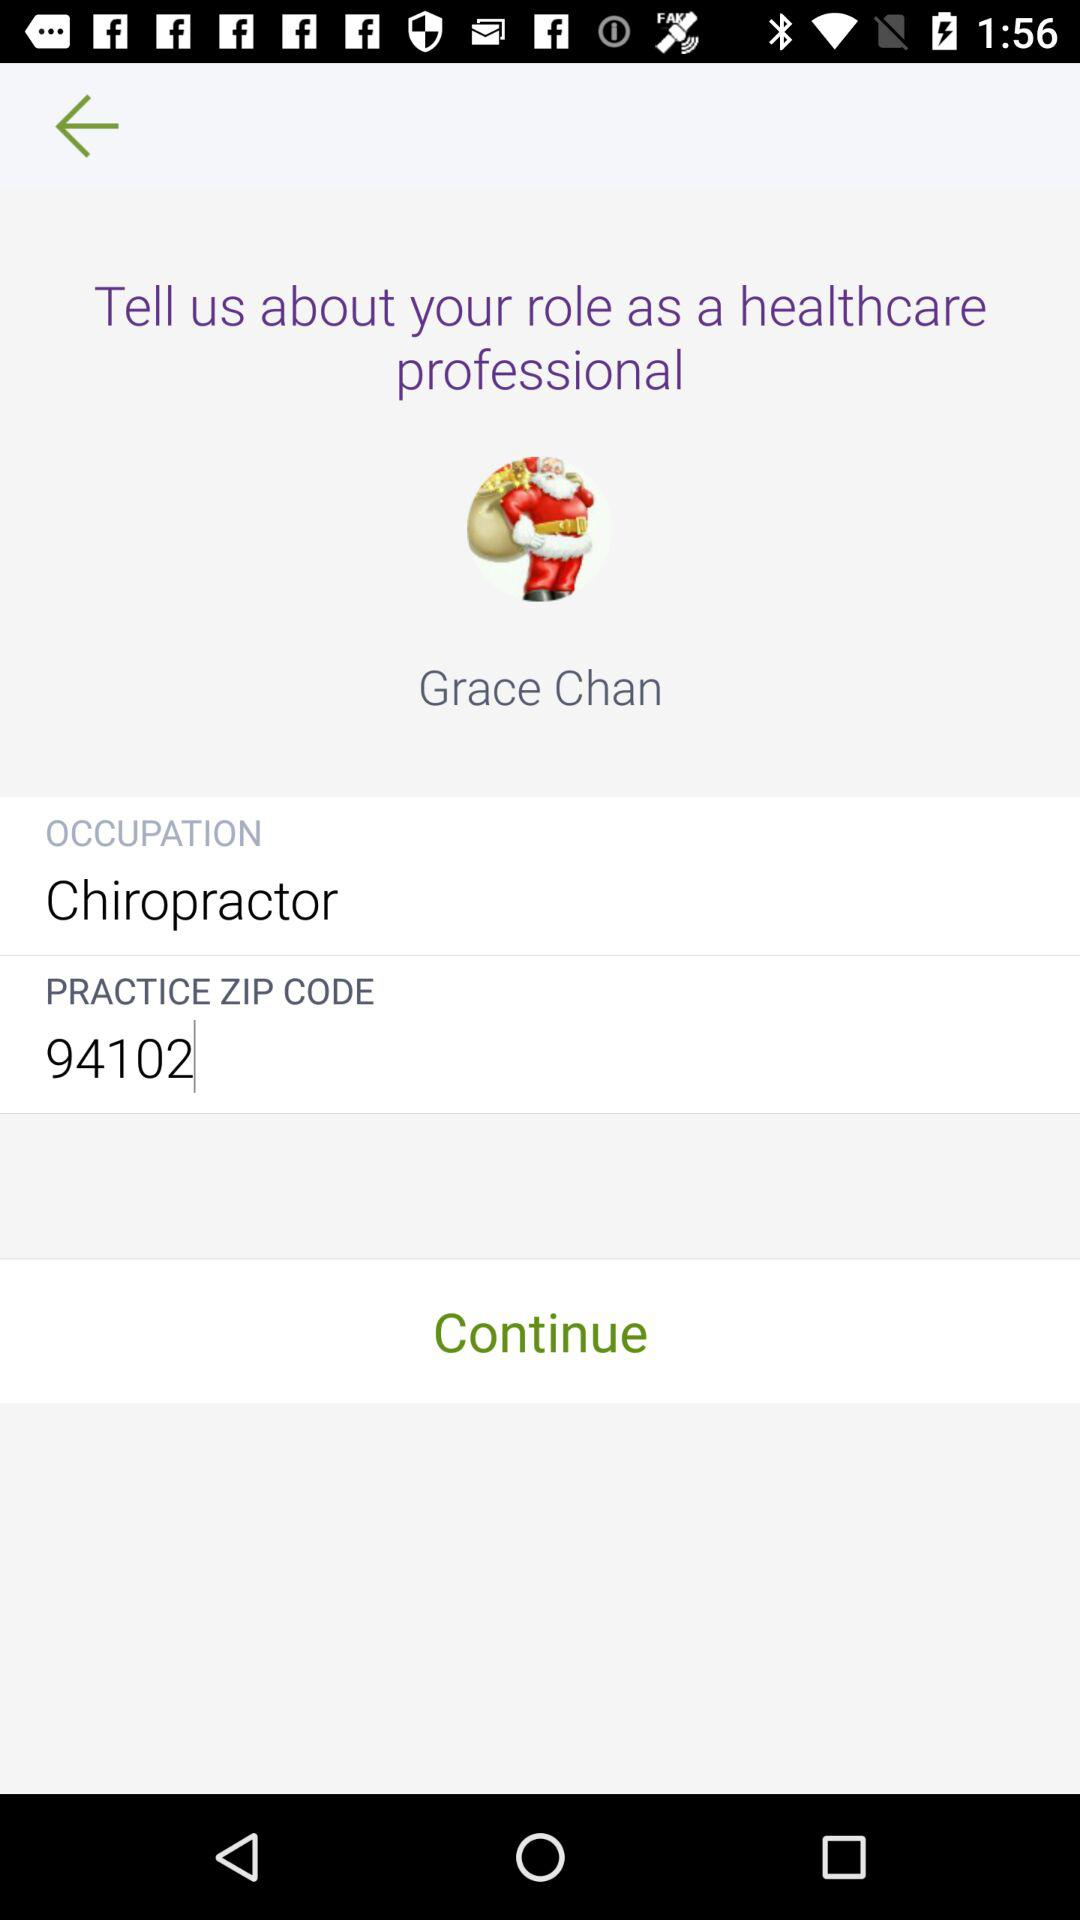What is the name of the user? The name of the user is Grace Chan. 